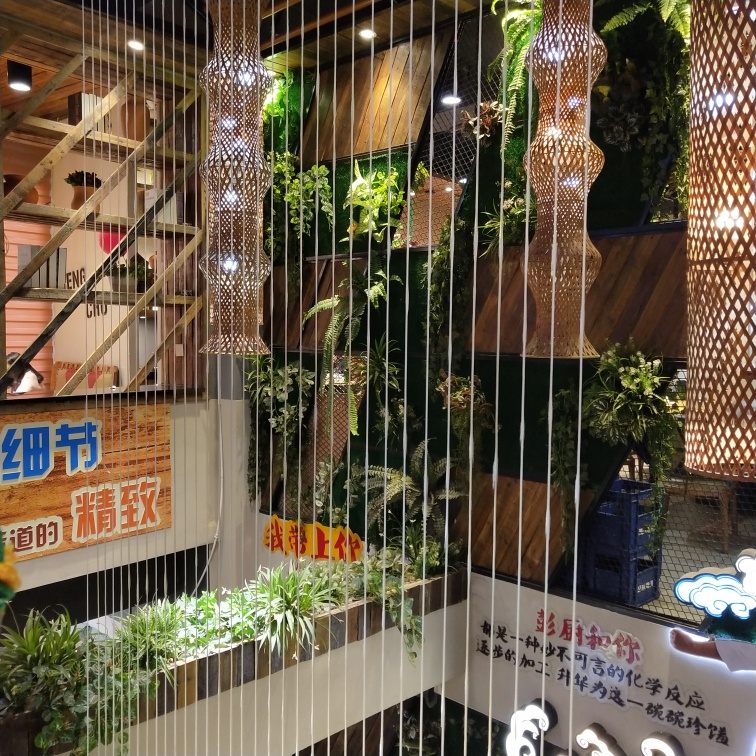What do you think is the atmosphere of the place shown in the image? The place shown in the image appears to have a cozy and inviting atmosphere, possibly a restaurant or café. The warm lighting and wooden decor elements create a welcoming ambiance. 